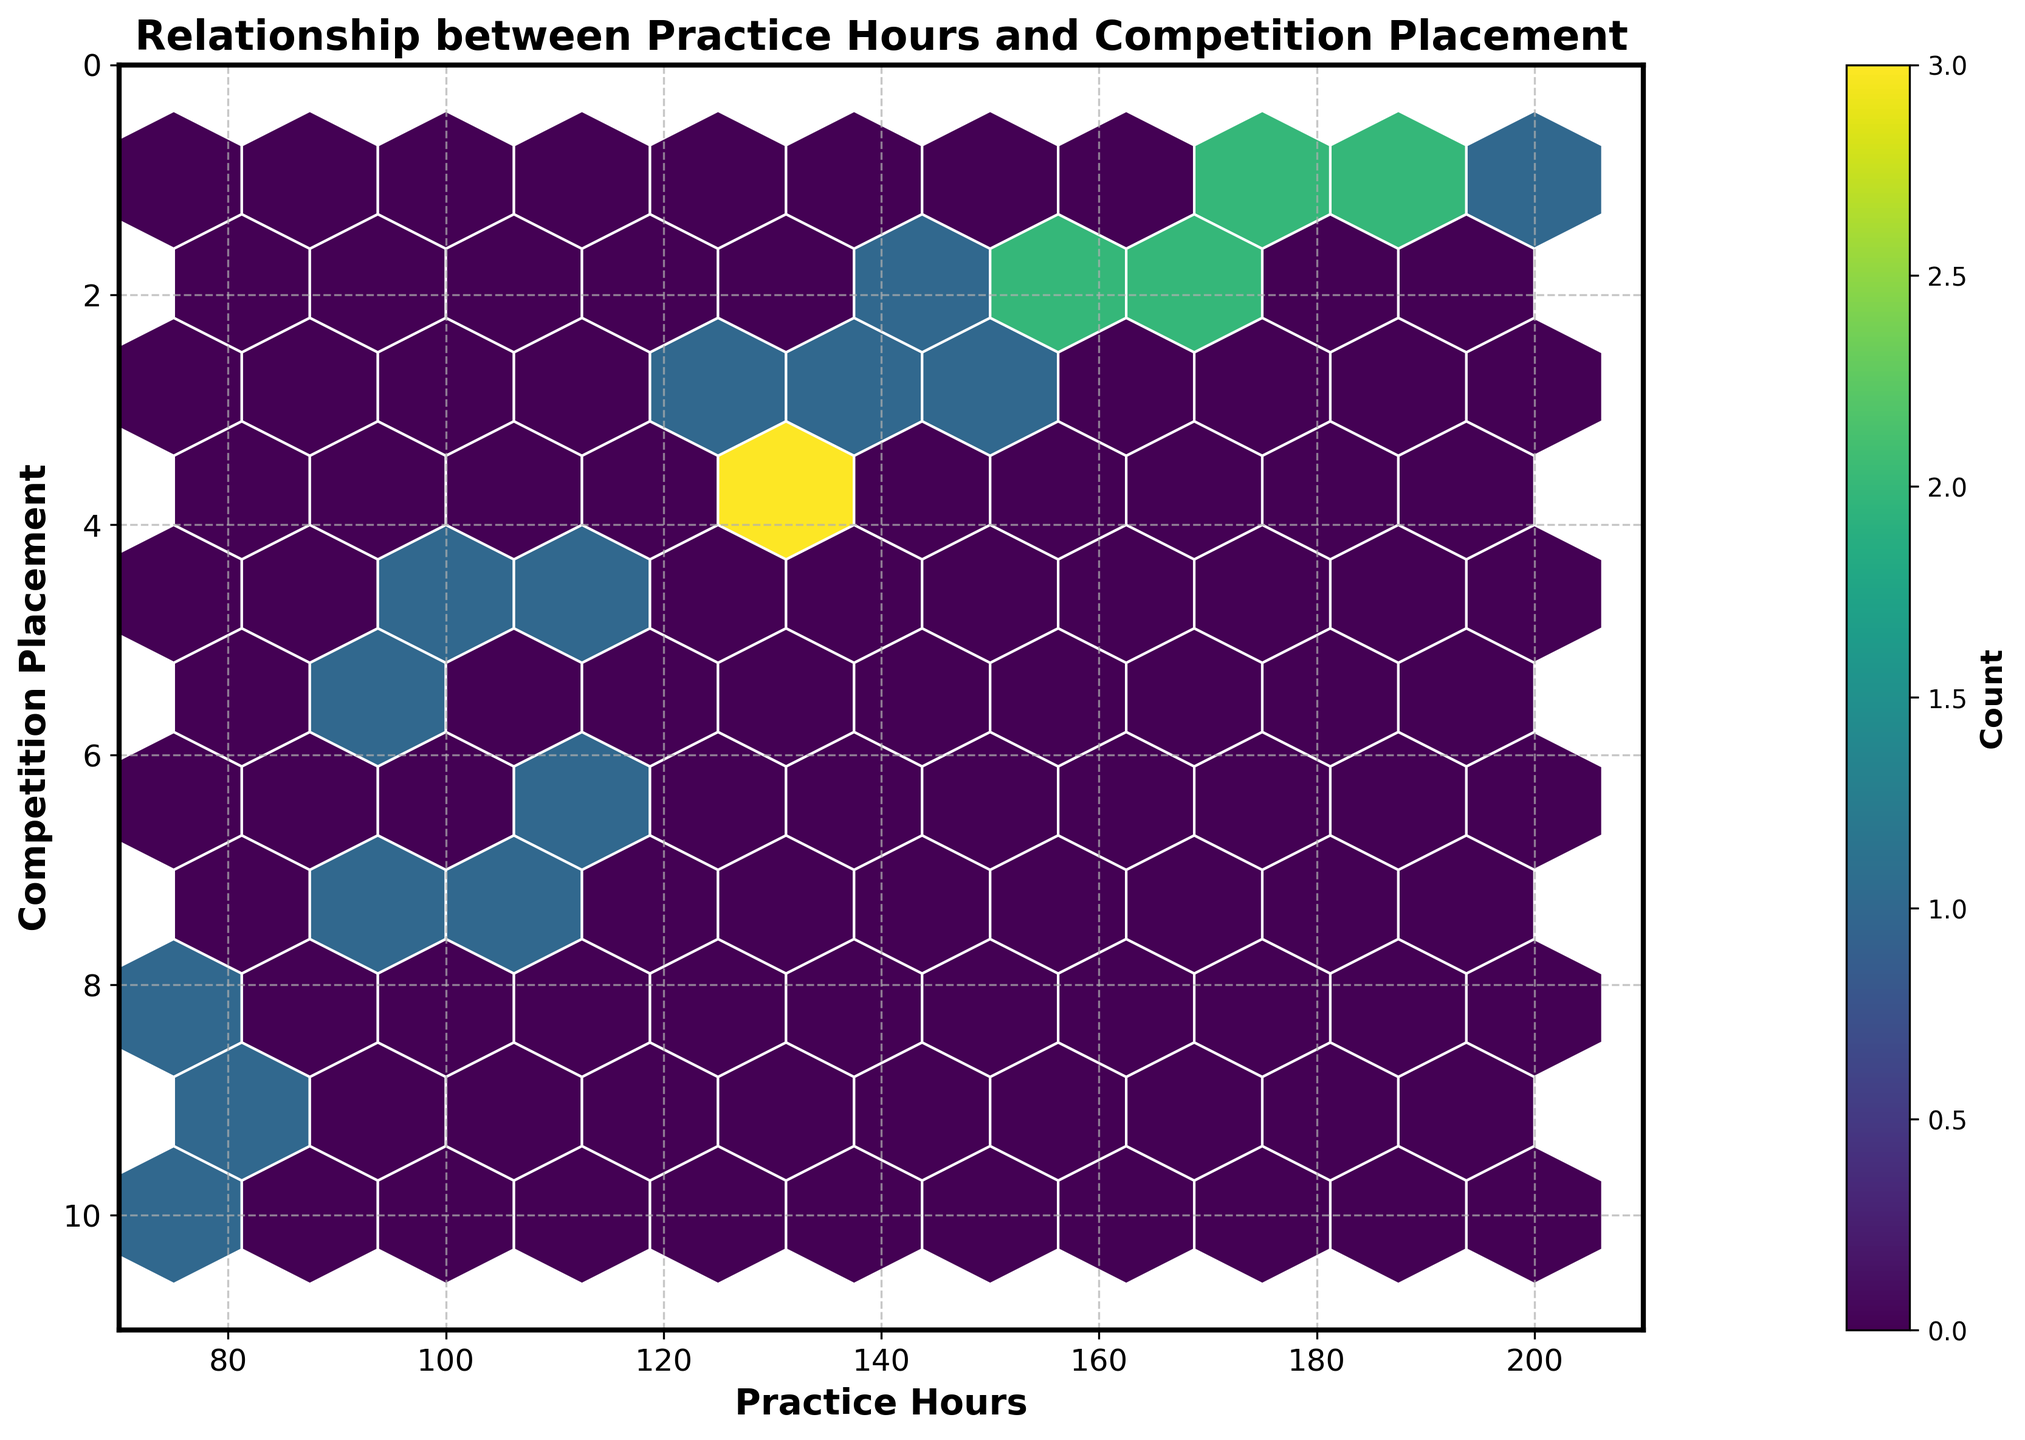what is the title of the chart? The title of the chart is usually displayed at the top. In this case, you would find it directly above the plot area.
Answer: Relationship between Practice Hours and Competition Placement what range do the x-axis values cover? Observing the x-axis, which represents practice hours, you can see that it starts from 70 and goes up to 210.
Answer: 70 to 210 What is the range of values for competition placements on the y-axis? Look at the y-axis to identify the range it covers. You will see it spans from 0 to 11.
Answer: 0 to 11 How many hexagons have a count higher than 3? Looking at the color bar and the hexagons, count the number of hexagons with a color corresponding to a count greater than 3 based on the color scale provided.
Answer: Two In which area of the plot do the highest densities of points appear? Examining the color intensities in the plot, the highest densities, represented by the darkest colors, appear in certain areas. These densest areas can be found by focusing on the regions with the highest intensity in color.
Answer: Around 150-170 practice hours and 1-2 competition placements What can you infer about the relationship between practice hours and competition placement from this plot? By analyzing the general trend and concentration of hexagons, you can infer that higher practice hours tend to be associated with better (lower-numbered) competition placements. This can be observed as the dense clusters with lower competition placements occurring in regions with higher practice hours.
Answer: More practice hours generally correlate with better competition placements 